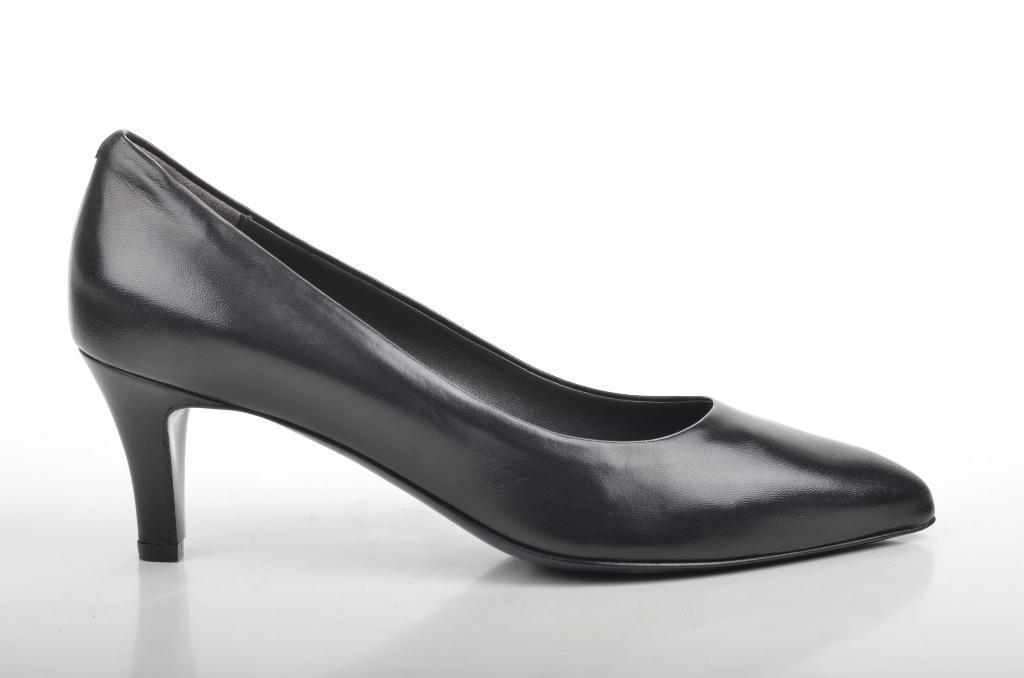What type of shoe heel is visible in the image? There is a black color shoe heel in the image. What is the shoe heel placed on in the image? The shoe heel is on an object. Can you see a hen interacting with the shoe heel in the image? There is no hen present in the image, and therefore no such interaction can be observed. Is there a snake visible near the shoe heel in the image? There is no snake present in the image, and therefore no such interaction can be observed. 